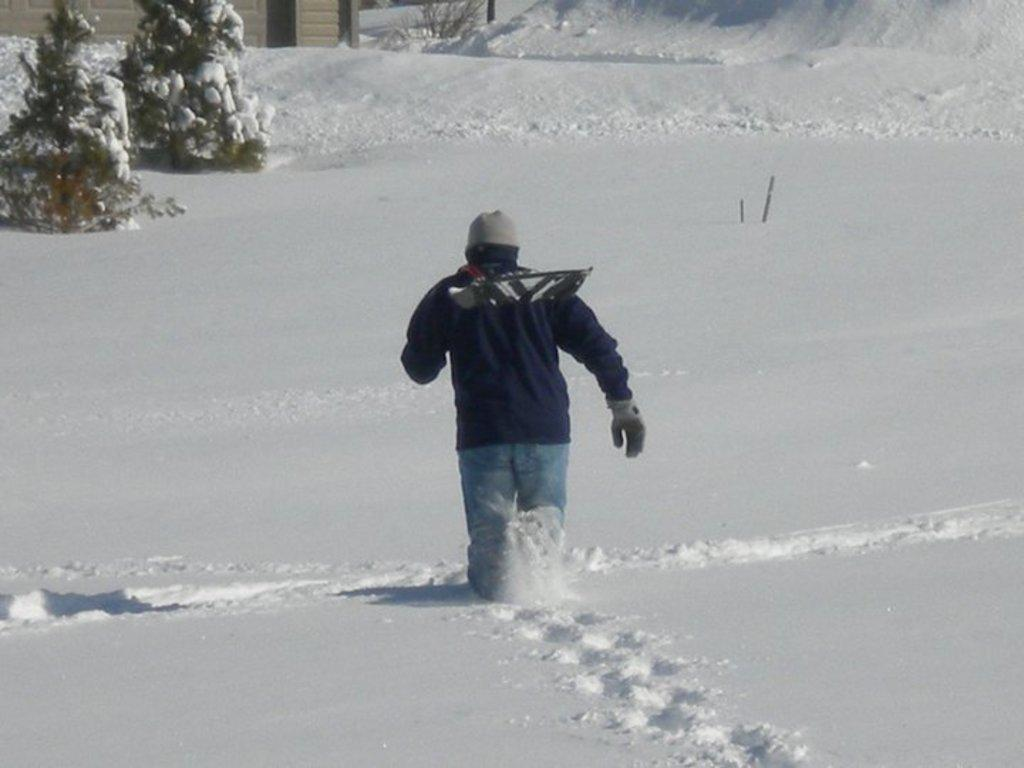What is the main subject of the image? There is a person in the image. What is the person holding in the image? The person is holding something. What is the person doing in the image? The person is walking. What is the person wearing in the image? The person is wearing a blue jacket and jeans. What is the weather like in the image? There is snow visible in the image. What can be seen in the background of the image? There are trees visible in the background of the image. Is the person's parent walking alongside them in the image? There is no indication of a parent or any other person in the image besides the person holding something and walking. Is the person a queen in the image? There is no indication of the person being a queen or holding any royal status in the image. 